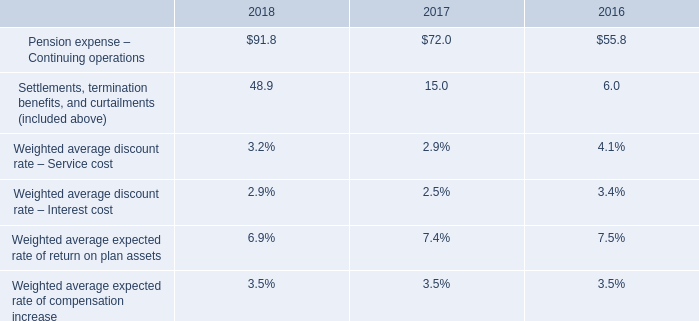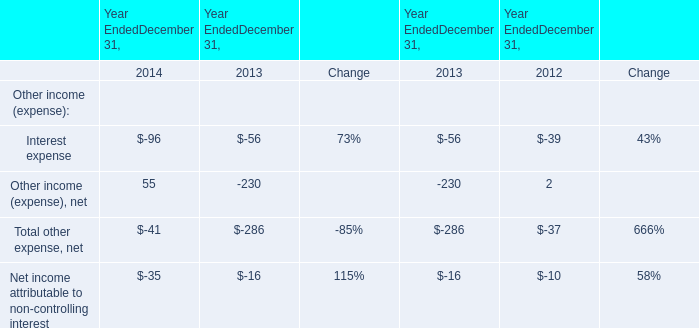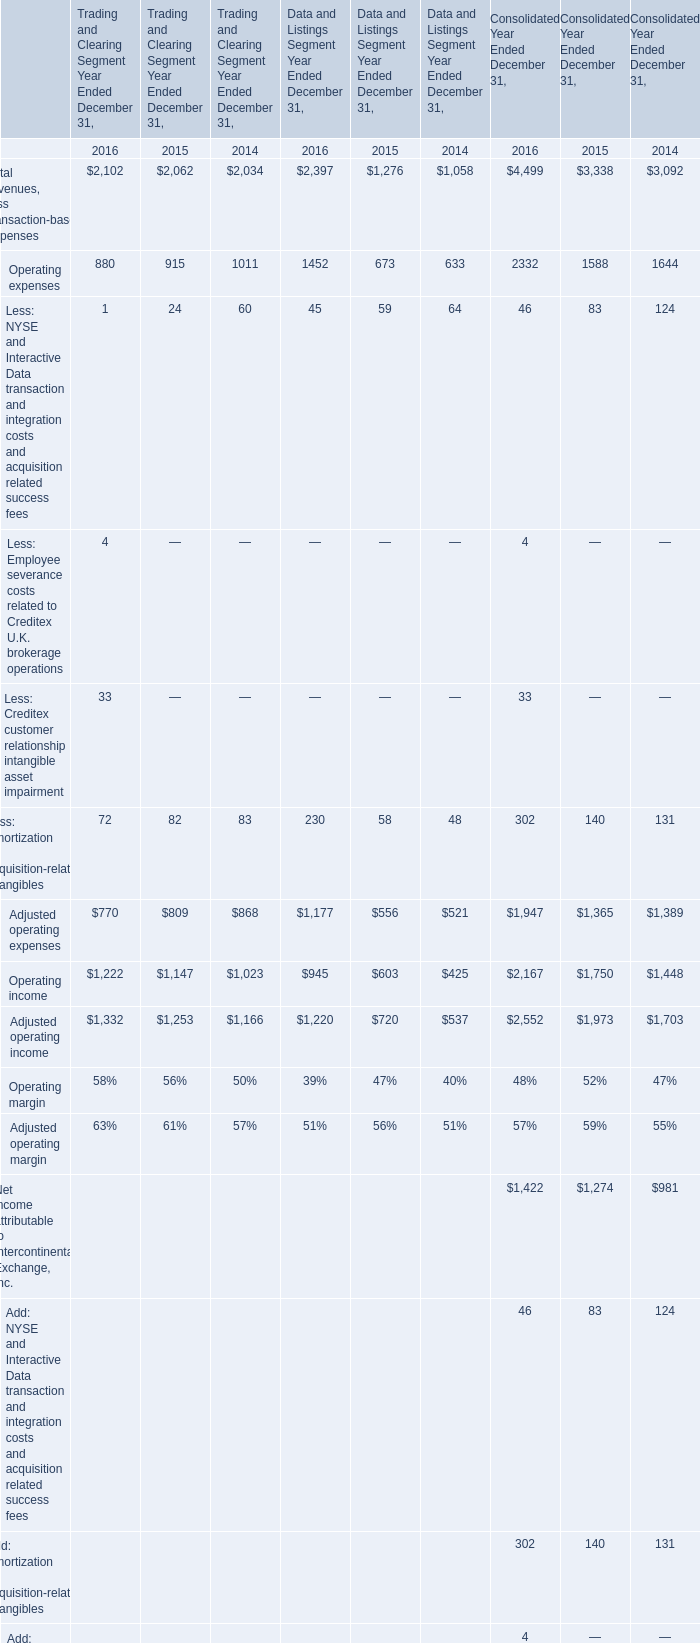what is the percentual increase in the operating expenses during 2017 and 2018? 
Computations: ((91.8 / 72.0) - 1)
Answer: 0.275. 